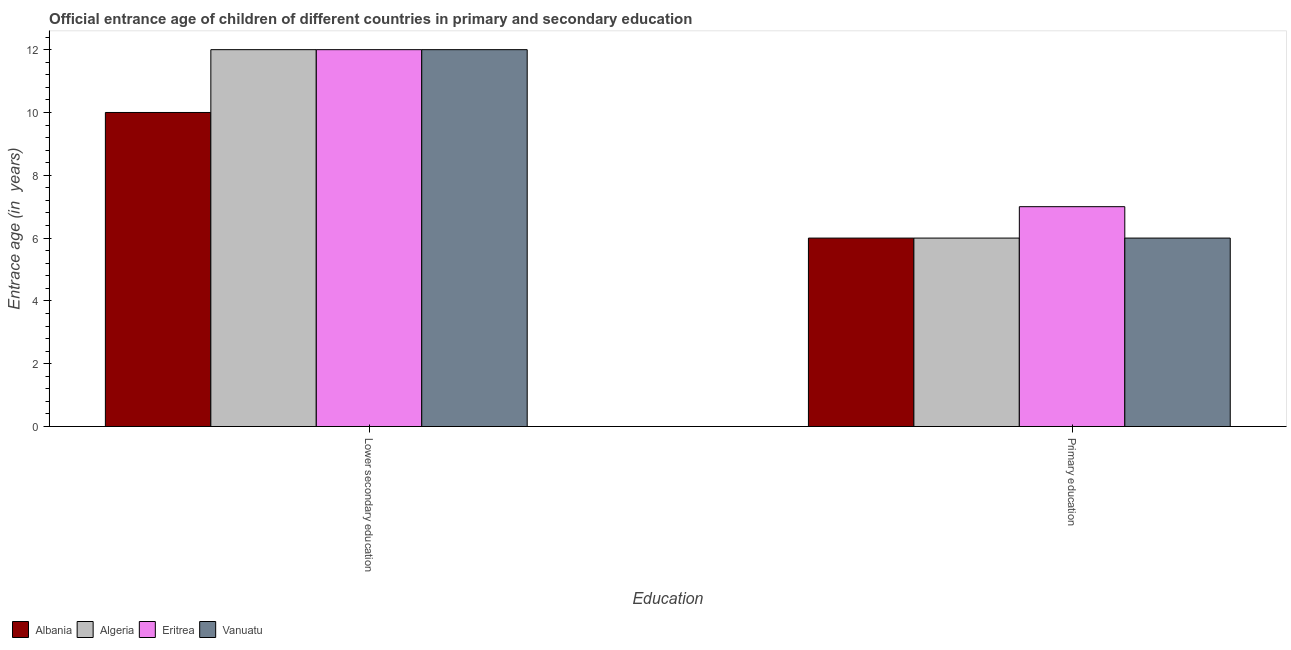Are the number of bars per tick equal to the number of legend labels?
Provide a short and direct response. Yes. How many bars are there on the 1st tick from the left?
Your answer should be very brief. 4. How many bars are there on the 1st tick from the right?
Your response must be concise. 4. What is the label of the 2nd group of bars from the left?
Ensure brevity in your answer.  Primary education. What is the entrance age of children in lower secondary education in Algeria?
Make the answer very short. 12. Across all countries, what is the maximum entrance age of children in lower secondary education?
Make the answer very short. 12. Across all countries, what is the minimum entrance age of children in lower secondary education?
Provide a short and direct response. 10. In which country was the entrance age of chiildren in primary education maximum?
Ensure brevity in your answer.  Eritrea. In which country was the entrance age of children in lower secondary education minimum?
Give a very brief answer. Albania. What is the total entrance age of chiildren in primary education in the graph?
Make the answer very short. 25. What is the difference between the entrance age of children in lower secondary education in Albania and the entrance age of chiildren in primary education in Eritrea?
Keep it short and to the point. 3. What is the average entrance age of chiildren in primary education per country?
Keep it short and to the point. 6.25. What is the difference between the entrance age of children in lower secondary education and entrance age of chiildren in primary education in Albania?
Your answer should be compact. 4. In how many countries, is the entrance age of chiildren in primary education greater than 1.2000000000000002 years?
Your answer should be compact. 4. What is the ratio of the entrance age of children in lower secondary education in Eritrea to that in Albania?
Provide a succinct answer. 1.2. Is the entrance age of children in lower secondary education in Eritrea less than that in Vanuatu?
Your answer should be very brief. No. In how many countries, is the entrance age of children in lower secondary education greater than the average entrance age of children in lower secondary education taken over all countries?
Your answer should be compact. 3. What does the 2nd bar from the left in Lower secondary education represents?
Your response must be concise. Algeria. What does the 1st bar from the right in Lower secondary education represents?
Your answer should be very brief. Vanuatu. How many countries are there in the graph?
Provide a short and direct response. 4. Are the values on the major ticks of Y-axis written in scientific E-notation?
Keep it short and to the point. No. Does the graph contain any zero values?
Give a very brief answer. No. Does the graph contain grids?
Provide a succinct answer. No. What is the title of the graph?
Make the answer very short. Official entrance age of children of different countries in primary and secondary education. Does "Portugal" appear as one of the legend labels in the graph?
Keep it short and to the point. No. What is the label or title of the X-axis?
Give a very brief answer. Education. What is the label or title of the Y-axis?
Offer a terse response. Entrace age (in  years). What is the Entrace age (in  years) of Algeria in Lower secondary education?
Provide a short and direct response. 12. What is the Entrace age (in  years) in Vanuatu in Lower secondary education?
Your answer should be compact. 12. What is the Entrace age (in  years) in Vanuatu in Primary education?
Give a very brief answer. 6. Across all Education, what is the maximum Entrace age (in  years) in Albania?
Provide a short and direct response. 10. Across all Education, what is the maximum Entrace age (in  years) in Vanuatu?
Give a very brief answer. 12. Across all Education, what is the minimum Entrace age (in  years) in Eritrea?
Provide a succinct answer. 7. Across all Education, what is the minimum Entrace age (in  years) in Vanuatu?
Provide a short and direct response. 6. What is the total Entrace age (in  years) of Eritrea in the graph?
Ensure brevity in your answer.  19. What is the difference between the Entrace age (in  years) of Algeria in Lower secondary education and that in Primary education?
Offer a terse response. 6. What is the difference between the Entrace age (in  years) in Vanuatu in Lower secondary education and that in Primary education?
Provide a short and direct response. 6. What is the difference between the Entrace age (in  years) in Albania in Lower secondary education and the Entrace age (in  years) in Eritrea in Primary education?
Provide a succinct answer. 3. What is the difference between the Entrace age (in  years) of Algeria in Lower secondary education and the Entrace age (in  years) of Vanuatu in Primary education?
Make the answer very short. 6. What is the difference between the Entrace age (in  years) in Eritrea in Lower secondary education and the Entrace age (in  years) in Vanuatu in Primary education?
Offer a terse response. 6. What is the difference between the Entrace age (in  years) in Albania and Entrace age (in  years) in Eritrea in Lower secondary education?
Your response must be concise. -2. What is the difference between the Entrace age (in  years) of Algeria and Entrace age (in  years) of Eritrea in Lower secondary education?
Make the answer very short. 0. What is the difference between the Entrace age (in  years) in Eritrea and Entrace age (in  years) in Vanuatu in Lower secondary education?
Your answer should be very brief. 0. What is the difference between the Entrace age (in  years) in Albania and Entrace age (in  years) in Algeria in Primary education?
Provide a short and direct response. 0. What is the difference between the Entrace age (in  years) in Albania and Entrace age (in  years) in Eritrea in Primary education?
Offer a terse response. -1. What is the difference between the Entrace age (in  years) in Albania and Entrace age (in  years) in Vanuatu in Primary education?
Your answer should be very brief. 0. What is the ratio of the Entrace age (in  years) in Albania in Lower secondary education to that in Primary education?
Offer a terse response. 1.67. What is the ratio of the Entrace age (in  years) of Algeria in Lower secondary education to that in Primary education?
Provide a short and direct response. 2. What is the ratio of the Entrace age (in  years) of Eritrea in Lower secondary education to that in Primary education?
Provide a short and direct response. 1.71. What is the difference between the highest and the second highest Entrace age (in  years) in Albania?
Give a very brief answer. 4. What is the difference between the highest and the lowest Entrace age (in  years) of Albania?
Your answer should be very brief. 4. What is the difference between the highest and the lowest Entrace age (in  years) of Algeria?
Keep it short and to the point. 6. What is the difference between the highest and the lowest Entrace age (in  years) in Eritrea?
Your answer should be very brief. 5. What is the difference between the highest and the lowest Entrace age (in  years) of Vanuatu?
Provide a succinct answer. 6. 